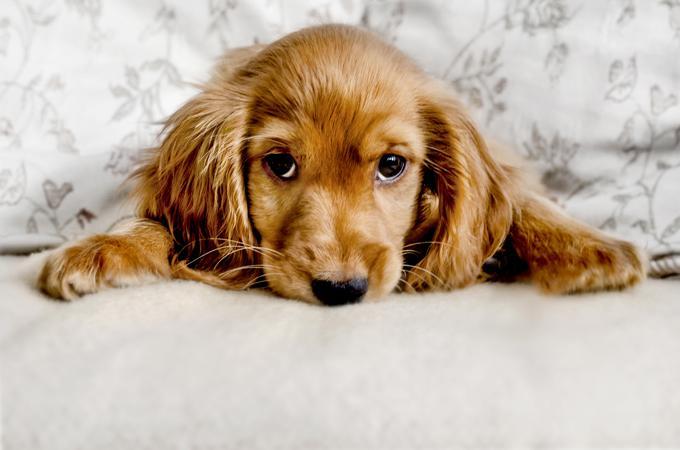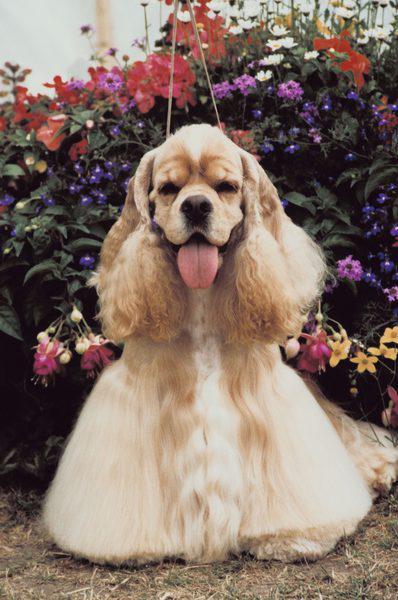The first image is the image on the left, the second image is the image on the right. Analyze the images presented: Is the assertion "An upright cocket spaniel is outdoors and has its tongue extended but not licking its nose." valid? Answer yes or no. Yes. The first image is the image on the left, the second image is the image on the right. Assess this claim about the two images: "A single dog is on grass". Correct or not? Answer yes or no. No. 